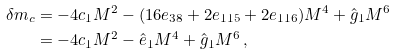Convert formula to latex. <formula><loc_0><loc_0><loc_500><loc_500>\delta m _ { c } & = - 4 c _ { 1 } M ^ { 2 } - ( 1 6 e _ { 3 8 } + 2 e _ { 1 1 5 } + 2 e _ { 1 1 6 } ) M ^ { 4 } + \hat { g } _ { 1 } M ^ { 6 } \, \\ & = - 4 c _ { 1 } M ^ { 2 } - \hat { e } _ { 1 } M ^ { 4 } + \hat { g } _ { 1 } M ^ { 6 } \, ,</formula> 